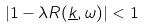<formula> <loc_0><loc_0><loc_500><loc_500>| 1 - \lambda R ( \underline { k } , \omega ) | < 1</formula> 